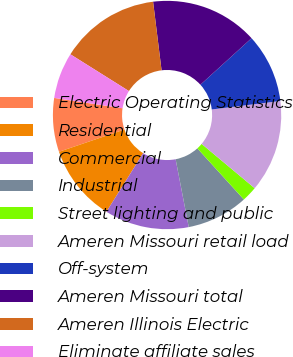Convert chart. <chart><loc_0><loc_0><loc_500><loc_500><pie_chart><fcel>Electric Operating Statistics<fcel>Residential<fcel>Commercial<fcel>Industrial<fcel>Street lighting and public<fcel>Ameren Missouri retail load<fcel>Off-system<fcel>Ameren Missouri total<fcel>Ameren Illinois Electric<fcel>Eliminate affiliate sales<nl><fcel>7.61%<fcel>10.87%<fcel>11.95%<fcel>8.7%<fcel>2.18%<fcel>13.04%<fcel>9.78%<fcel>15.21%<fcel>14.12%<fcel>6.53%<nl></chart> 